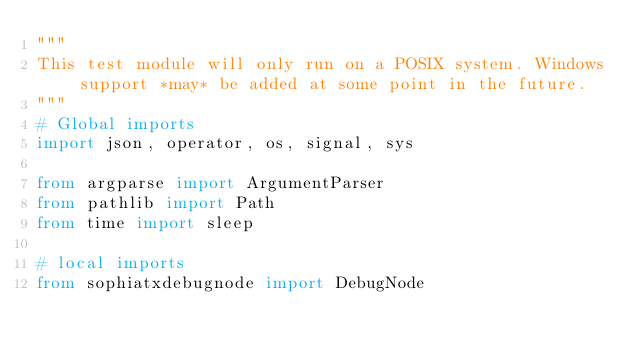Convert code to text. <code><loc_0><loc_0><loc_500><loc_500><_Python_>"""
This test module will only run on a POSIX system. Windows support *may* be added at some point in the future.
"""
# Global imports
import json, operator, os, signal, sys

from argparse import ArgumentParser
from pathlib import Path
from time import sleep

# local imports
from sophiatxdebugnode import DebugNode</code> 